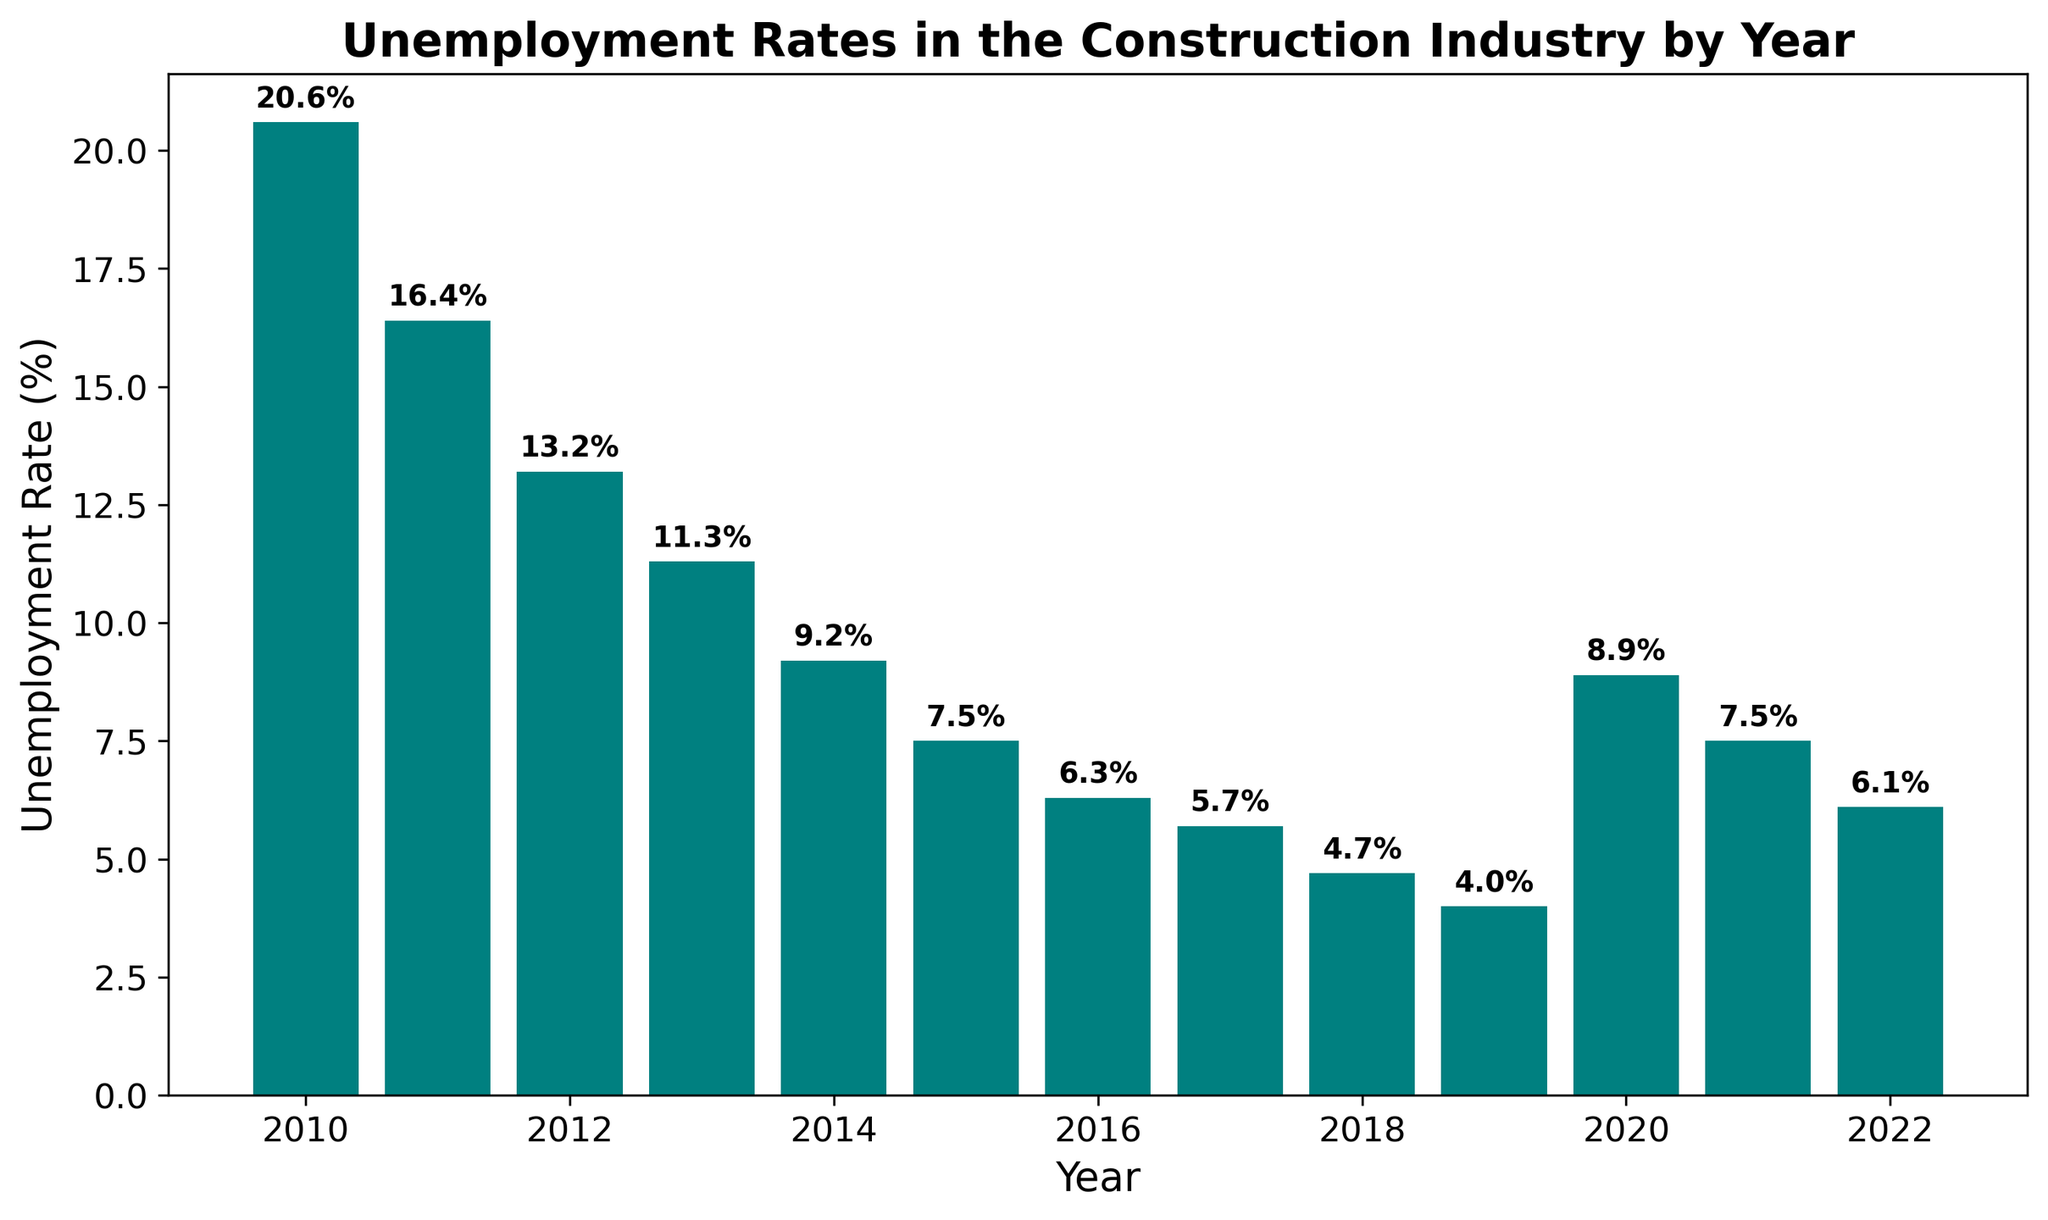What's the lowest unemployment rate between 2010 and 2022? To find the lowest unemployment rate, we look at the height of the bars and identify the shortest bar. The shortest bar on the chart corresponds to the year 2019 with a rate of 4.0%.
Answer: 4.0% Which year experienced the highest unemployment rate in the given timeframe? To identify the highest unemployment rate, we need to find the tallest bar. The tallest bar represents the year 2010, with an unemployment rate of 20.6%.
Answer: 2010 How did the unemployment rate change from 2010 to 2022? The rate started at 20.6% in 2010, decreased steadily year by year until 2019, which had the lowest rate at 4.0%, increased again in 2020 to 8.9%, and then decreased again to 6.1% in 2022. Overall, the trend was a significant decline from 2010 to 2022 despite some minor fluctuations.
Answer: Decreased What’s the average unemployment rate for the years 2015 to 2020? To find the average, sum the rates from 2015 to 2020 and divide by the number of years. The rates are: 7.5, 6.3, 5.7, 4.7, 4.0, and 8.9. Sum = 37.1. Average = 37.1 / 6 = 6.18%.
Answer: 6.18% In which years was the unemployment rate higher than 10%? We need to identify the bars that are taller than the 10% level. The years with rates higher than 10% are 2010, 2011, 2012, and 2013.
Answer: 2010, 2011, 2012, 2013 Compare the unemployment rates of 2014 and 2020. Which was higher and by how much? The rate for 2014 was 9.2% and for 2020 was 8.9%. Subtract the lower rate from the higher rate to get the difference: 9.2% - 8.9% = 0.3%. Therefore, 2014's rate was higher by 0.3%.
Answer: 2014 by 0.3% What’s the combined unemployment rate for the years 2011, 2012, and 2013? To find the combined rate, we sum the rates for the years 2011, 2012, and 2013. The rates are: 16.4, 13.2, and 11.3. Combined rate = 16.4 + 13.2 + 11.3 = 40.9%.
Answer: 40.9% How many years had unemployment rates below 10%? We count the bars that are below the 10% mark. These years are: 2014, 2015, 2016, 2017, 2018, 2019, 2020, 2021, and 2022. There are 9 years in total.
Answer: 9 years Did any years have the same unemployment rate? We need to visually inspect the bars to see if any of them have the exact same height. The years 2015 and 2021 both have an unemployment rate of 7.5%.
Answer: Yes, 2015 and 2021 What's the percentage decrease in unemployment rate from 2010 to 2019? First, we calculate the difference: 20.6% (2010) - 4.0% (2019) = 16.6%. Then, we divide by the initial rate (2010): (16.6 / 20.6) * 100 = approximately 80.58%.
Answer: 80.58% 